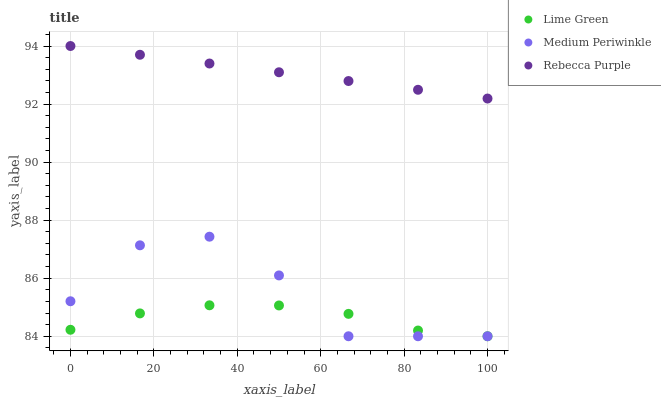Does Lime Green have the minimum area under the curve?
Answer yes or no. Yes. Does Rebecca Purple have the maximum area under the curve?
Answer yes or no. Yes. Does Rebecca Purple have the minimum area under the curve?
Answer yes or no. No. Does Lime Green have the maximum area under the curve?
Answer yes or no. No. Is Rebecca Purple the smoothest?
Answer yes or no. Yes. Is Medium Periwinkle the roughest?
Answer yes or no. Yes. Is Lime Green the smoothest?
Answer yes or no. No. Is Lime Green the roughest?
Answer yes or no. No. Does Medium Periwinkle have the lowest value?
Answer yes or no. Yes. Does Rebecca Purple have the lowest value?
Answer yes or no. No. Does Rebecca Purple have the highest value?
Answer yes or no. Yes. Does Lime Green have the highest value?
Answer yes or no. No. Is Medium Periwinkle less than Rebecca Purple?
Answer yes or no. Yes. Is Rebecca Purple greater than Medium Periwinkle?
Answer yes or no. Yes. Does Lime Green intersect Medium Periwinkle?
Answer yes or no. Yes. Is Lime Green less than Medium Periwinkle?
Answer yes or no. No. Is Lime Green greater than Medium Periwinkle?
Answer yes or no. No. Does Medium Periwinkle intersect Rebecca Purple?
Answer yes or no. No. 